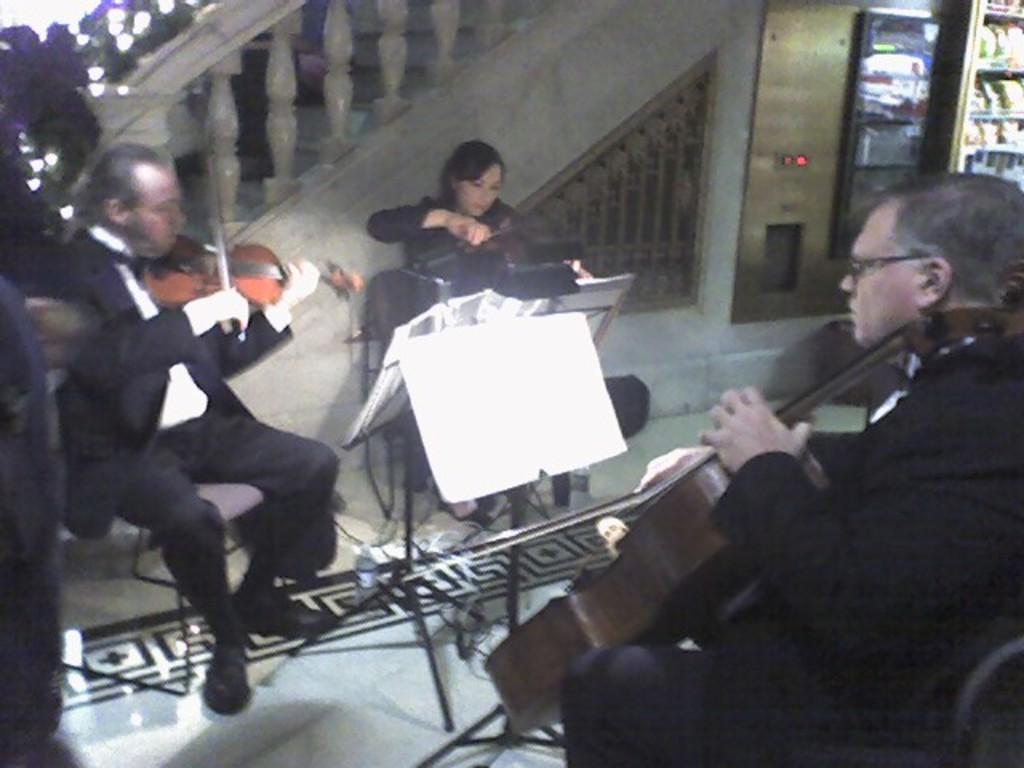Can you describe this image briefly? In this image we can see group of persons wearing coat are holding a violin in their hands. In the center of the image we can see a book placed on a stand. In the background, we can see group of items place in racks and a staircase. 